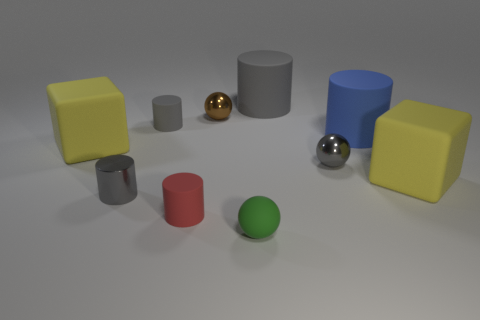Subtract all red balls. How many gray cylinders are left? 3 Subtract all gray matte cylinders. How many cylinders are left? 3 Subtract 1 cylinders. How many cylinders are left? 4 Subtract all blue cylinders. How many cylinders are left? 4 Subtract all cyan cylinders. Subtract all cyan spheres. How many cylinders are left? 5 Subtract all blocks. How many objects are left? 8 Add 5 brown shiny objects. How many brown shiny objects exist? 6 Subtract 1 blue cylinders. How many objects are left? 9 Subtract all big red matte balls. Subtract all spheres. How many objects are left? 7 Add 4 gray shiny objects. How many gray shiny objects are left? 6 